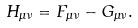Convert formula to latex. <formula><loc_0><loc_0><loc_500><loc_500>H _ { \mu \nu } = F _ { \mu \nu } - G _ { \mu \nu } .</formula> 